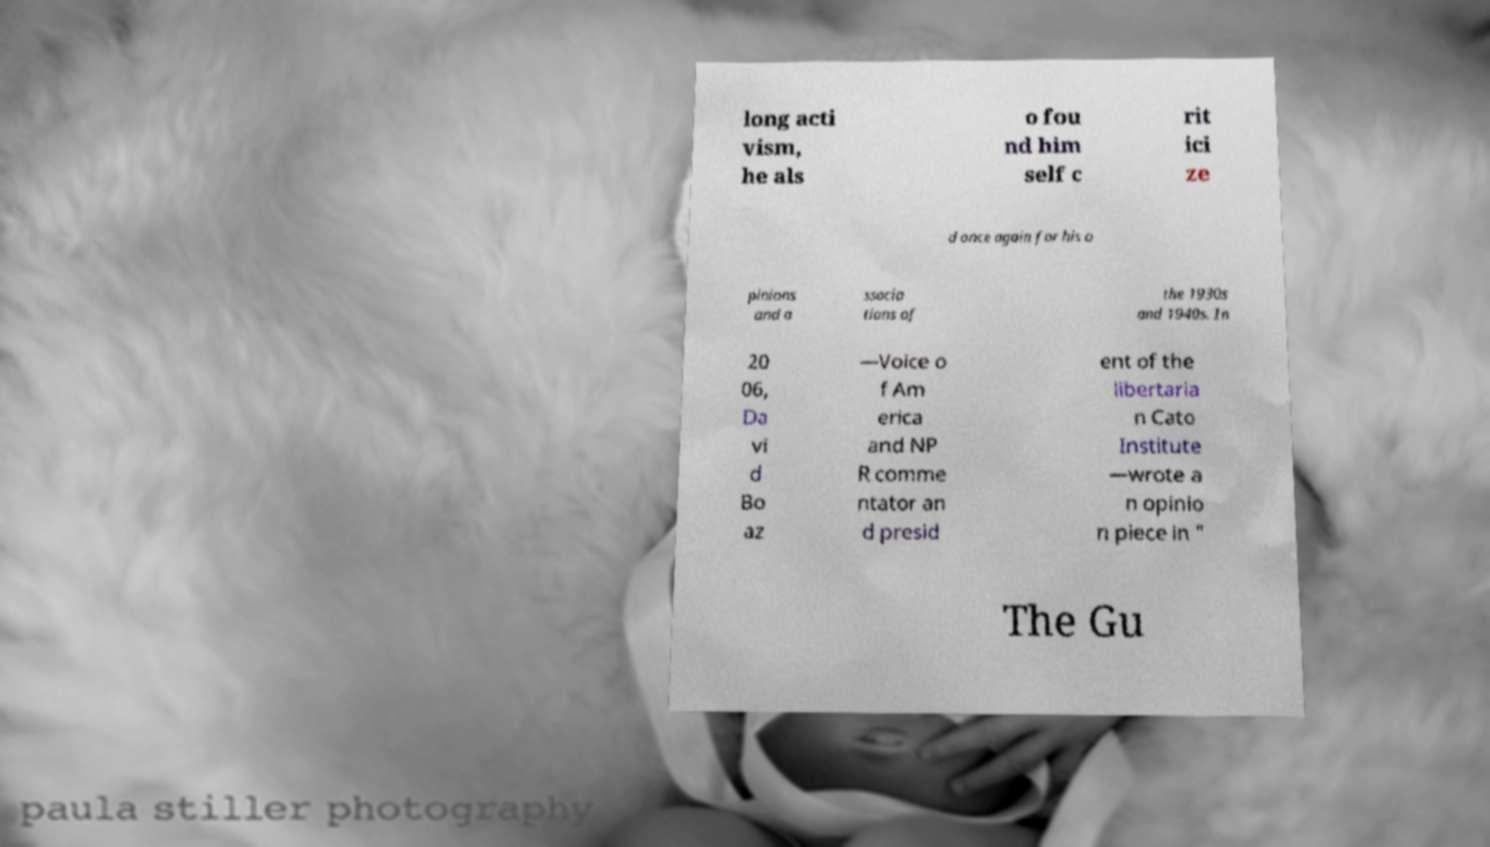Could you extract and type out the text from this image? long acti vism, he als o fou nd him self c rit ici ze d once again for his o pinions and a ssocia tions of the 1930s and 1940s. In 20 06, Da vi d Bo az —Voice o f Am erica and NP R comme ntator an d presid ent of the libertaria n Cato Institute —wrote a n opinio n piece in " The Gu 